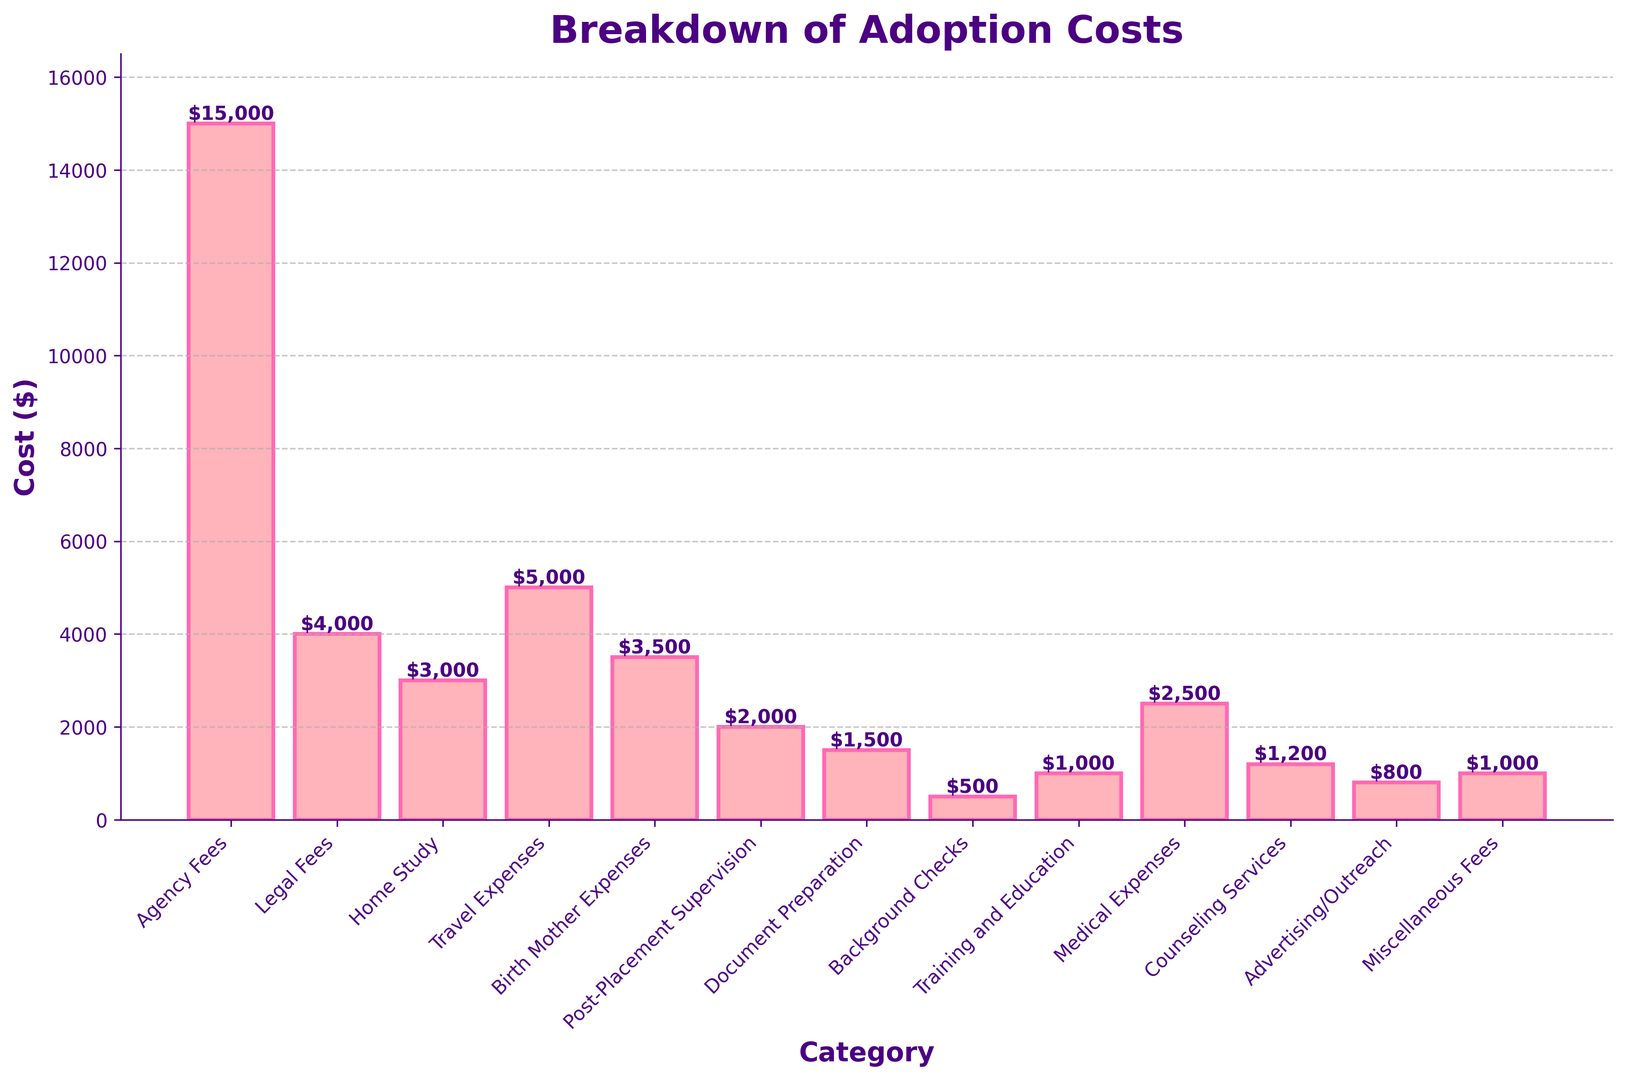What is the total cost of Agency Fees and Legal Fees? To find the total cost, add the cost of Agency Fees ($15,000) and Legal Fees ($4,000). This results in $19,000.
Answer: $19,000 Which category has the highest cost? Examine the heights of the bars. The bar representing Agency Fees is the tallest, indicating the highest cost.
Answer: Agency Fees Which category has the lowest cost? Observe the shortest bar in the chart, which is for Background Checks with a cost of $500.
Answer: Background Checks What are the total costs of Home Study, Medical Expenses, and Counseling Services combined? Add the cost of Home Study ($3,000), Medical Expenses ($2,500), and Counseling Services ($1,200). The total is $6,700.
Answer: $6,700 How much more expensive are Travel Expenses compared to Home Study? Subtract the cost of Home Study ($3,000) from the cost of Travel Expenses ($5,000). The difference is $2,000.
Answer: $2,000 How many categories have costs greater than $3,000? Count the bars that exceed the $3,000 mark. Agency Fees, Travel Expenses, Birth Mother Expenses, and Medical Expenses meet this criterion. There are 4 such categories.
Answer: 4 Is the cost of Post-Placement Supervision more or less than $3,000? Check the height of the Post-Placement Supervision bar, which is at $2,000, less than $3,000.
Answer: Less than $3,000 What is the average cost of the categories specifically labeled as Agency Fees, Legal Fees, and Travel Expenses? Add the costs of Agency Fees ($15,000), Legal Fees ($4,000), and Travel Expenses ($5,000). Divide this total ($24,000) by 3; the result is $8,000.
Answer: $8,000 How does the cost of Advertising/Outreach compare to that of Training and Education? Compare the heights of the bars for Advertising/Outreach ($800) and Training and Education ($1,000). Advertising/Outreach is $200 less.
Answer: $200 less What is the cost difference between the highest (Agency Fees) and lowest (Background Checks) categories? Subtract the cost of Background Checks ($500) from the cost of Agency Fees ($15,000). The difference is $14,500.
Answer: $14,500 